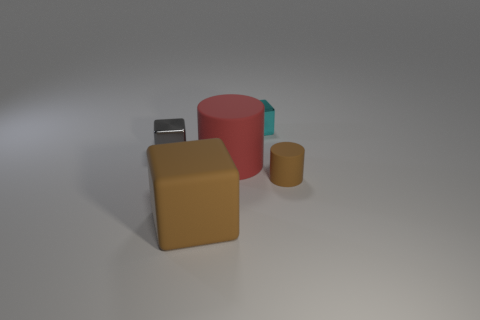Can you describe the setting of this image? The image has a simplistic and abstract setting, with no identifiable background or context other than a greyish, nondescript surface upon which the objects rest. It appears to be a controlled environment like a photo studio, intended to highlight the objects without any background distractions. 